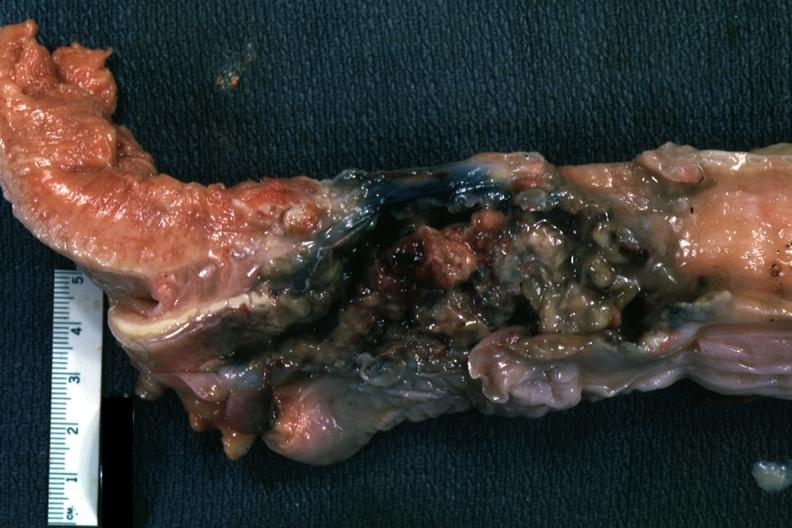where is this?
Answer the question using a single word or phrase. Oral 